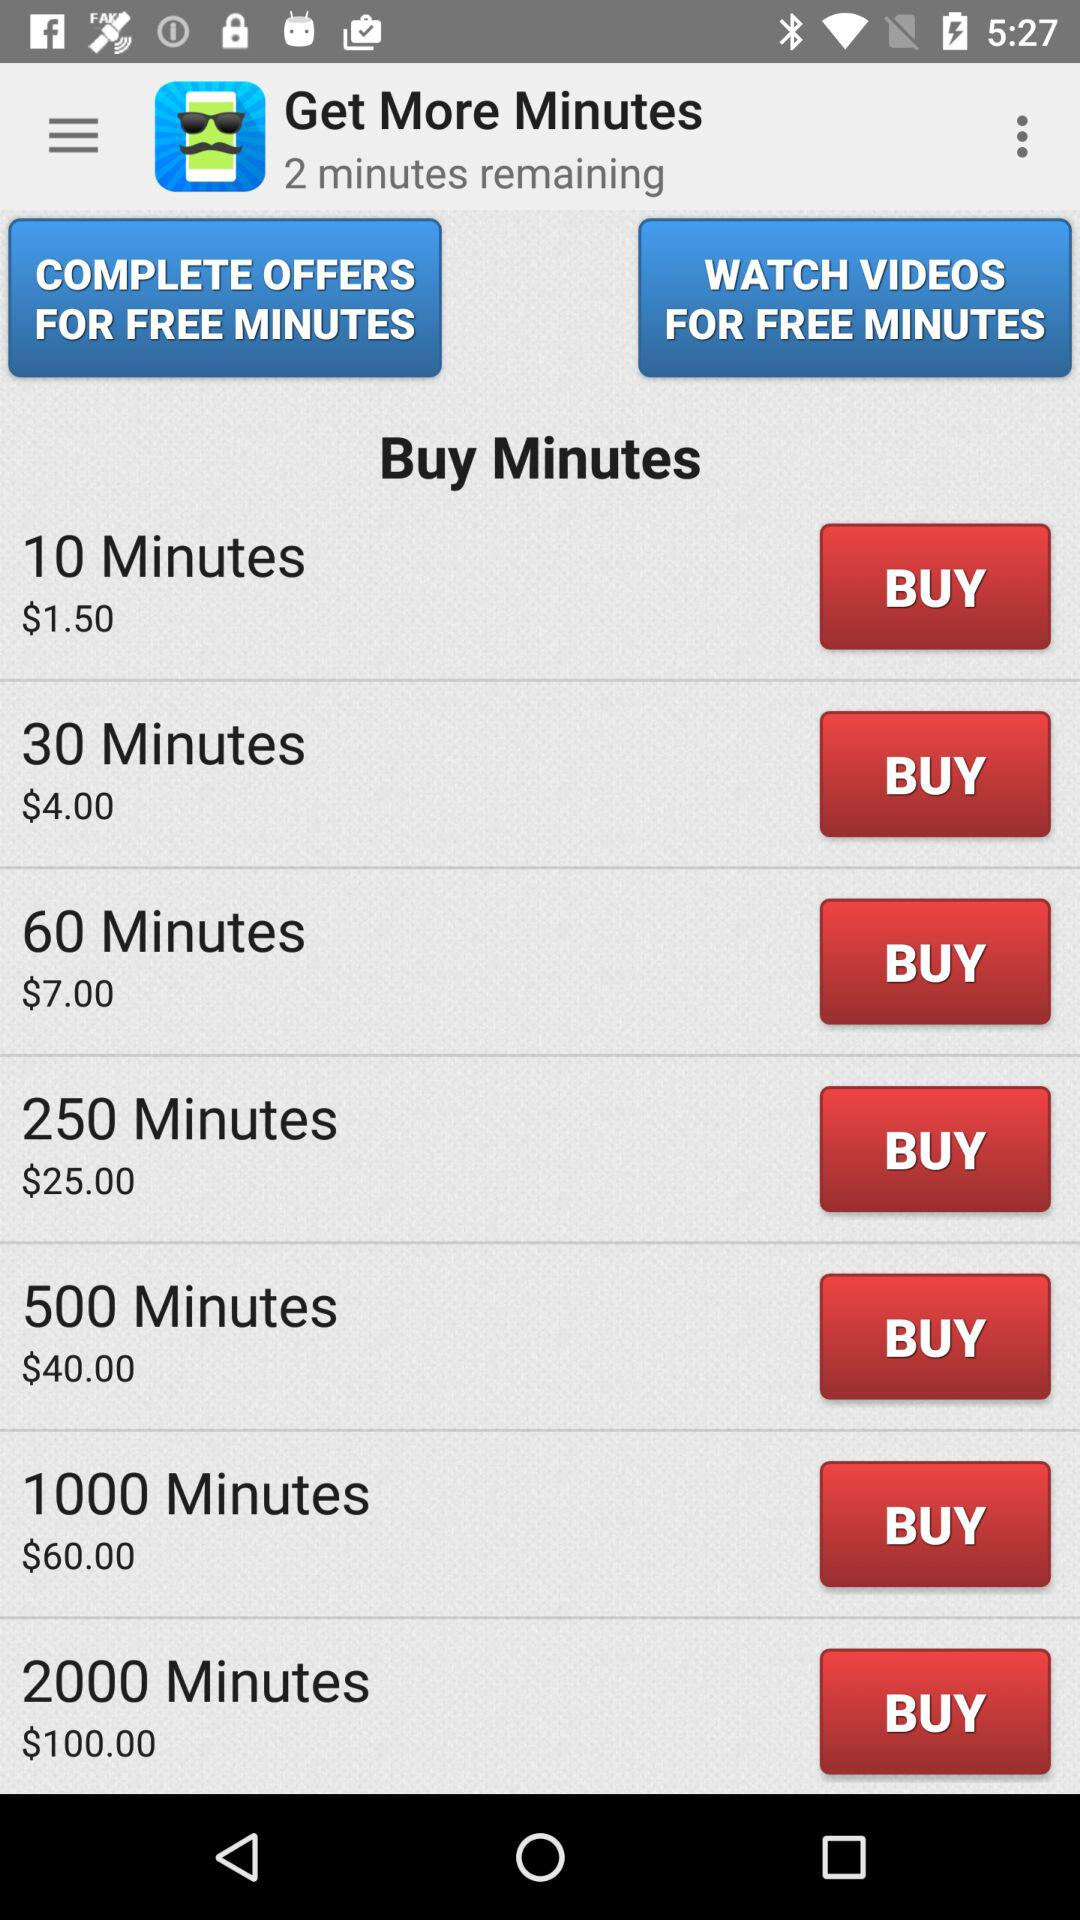What is the currency of price? The currency of price is the dollar. 